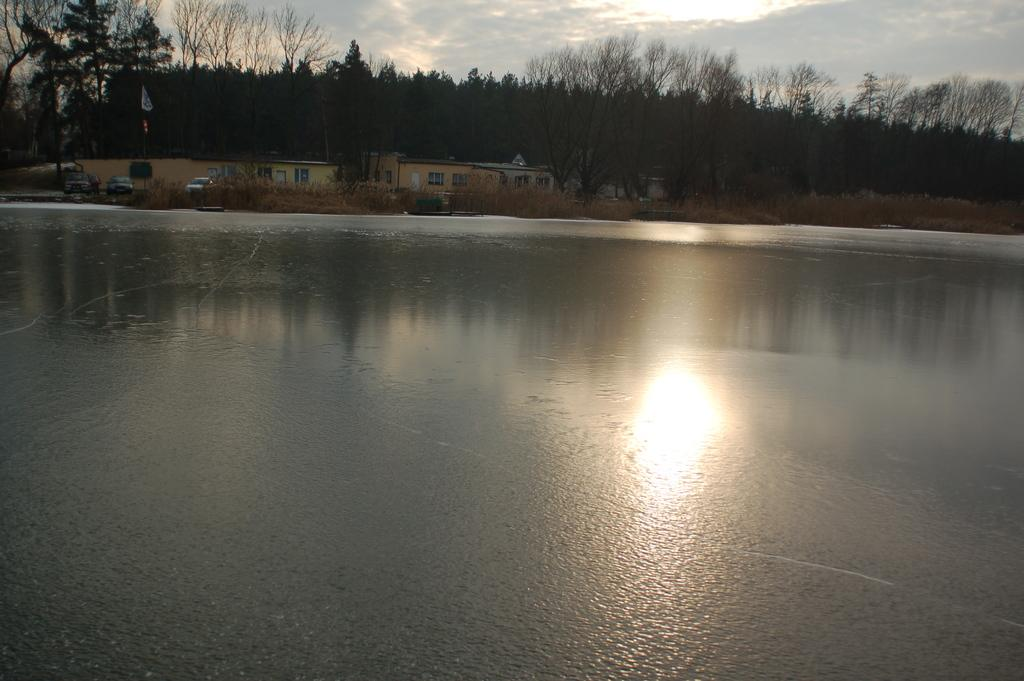What is visible in the foreground of the image? There is water in the foreground of the image. What can be seen in the background of the image? There are houses and trees in the background of the image. How would you describe the sky in the image? The sky is cloudy at the top of the image. What type of hand can be seen reaching for the clouds in the image? There is no hand visible in the image; it only features water, houses, trees, and a cloudy sky. What kind of air is being used to fly the houses in the image? The houses are not flying in the image; they are stationary in the background. 